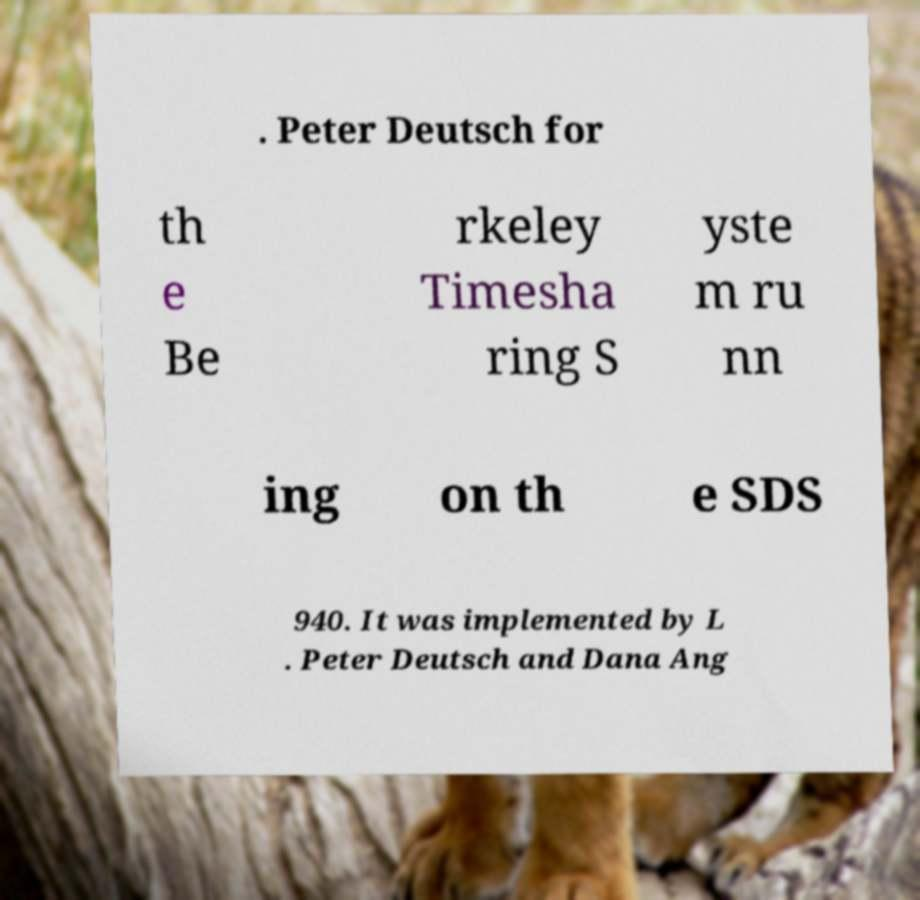Could you assist in decoding the text presented in this image and type it out clearly? . Peter Deutsch for th e Be rkeley Timesha ring S yste m ru nn ing on th e SDS 940. It was implemented by L . Peter Deutsch and Dana Ang 